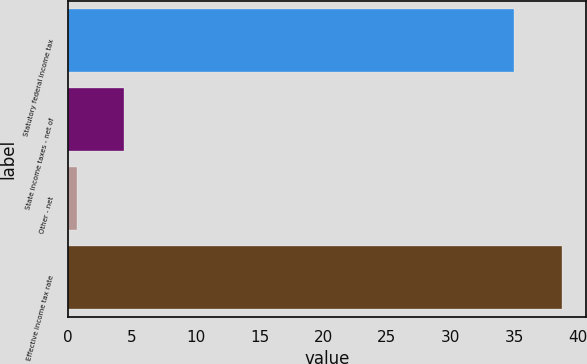Convert chart. <chart><loc_0><loc_0><loc_500><loc_500><bar_chart><fcel>Statutory federal income tax<fcel>State income taxes - net of<fcel>Other - net<fcel>Effective income tax rate<nl><fcel>35<fcel>4.41<fcel>0.7<fcel>38.71<nl></chart> 